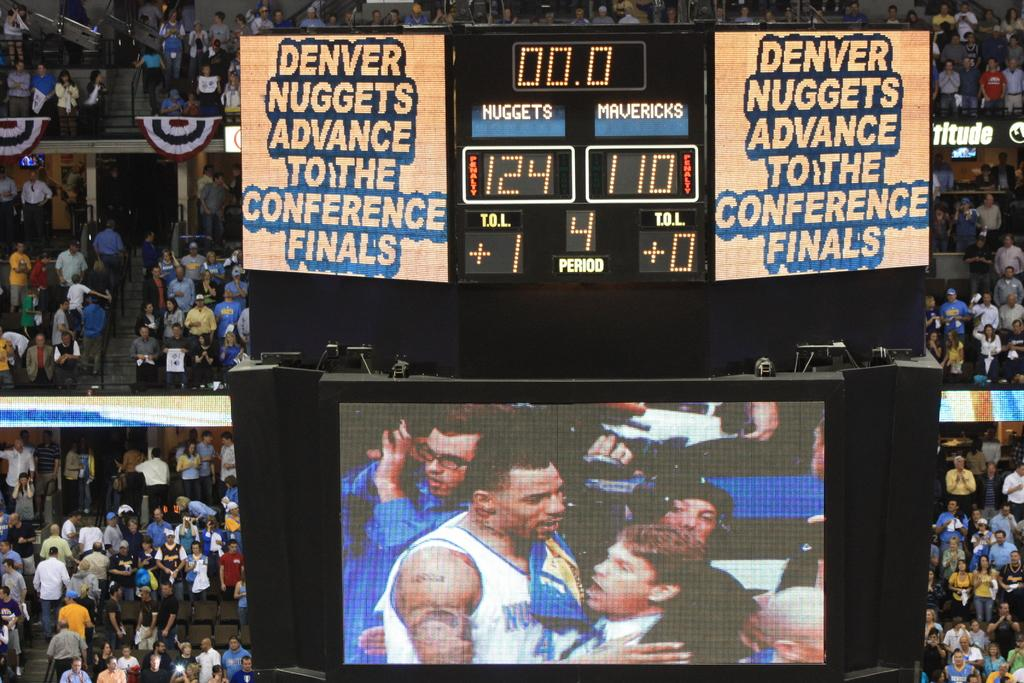<image>
Relay a brief, clear account of the picture shown. The Denver nuggets are celebrating going to the conference finals. 